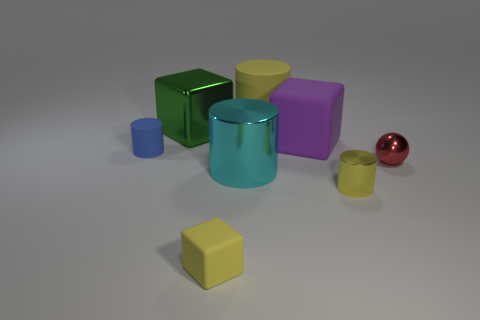How many other things are the same size as the cyan shiny object?
Provide a succinct answer. 3. Do the tiny rubber cube and the small metallic cylinder have the same color?
Your response must be concise. Yes. What is the material of the small red object?
Keep it short and to the point. Metal. Are there any other things of the same color as the metallic sphere?
Your response must be concise. No. Does the blue object have the same material as the green thing?
Provide a succinct answer. No. What number of rubber things are in front of the small cylinder left of the purple thing right of the large yellow cylinder?
Provide a short and direct response. 1. How many tiny purple matte balls are there?
Your answer should be compact. 0. Is the number of small rubber cylinders on the right side of the yellow matte cylinder less than the number of big cylinders that are behind the blue cylinder?
Offer a very short reply. Yes. Is the number of small cylinders that are to the left of the purple thing less than the number of green metallic blocks?
Make the answer very short. No. There is a big green object that is behind the small sphere in front of the yellow rubber thing that is behind the metallic block; what is its material?
Provide a short and direct response. Metal. 